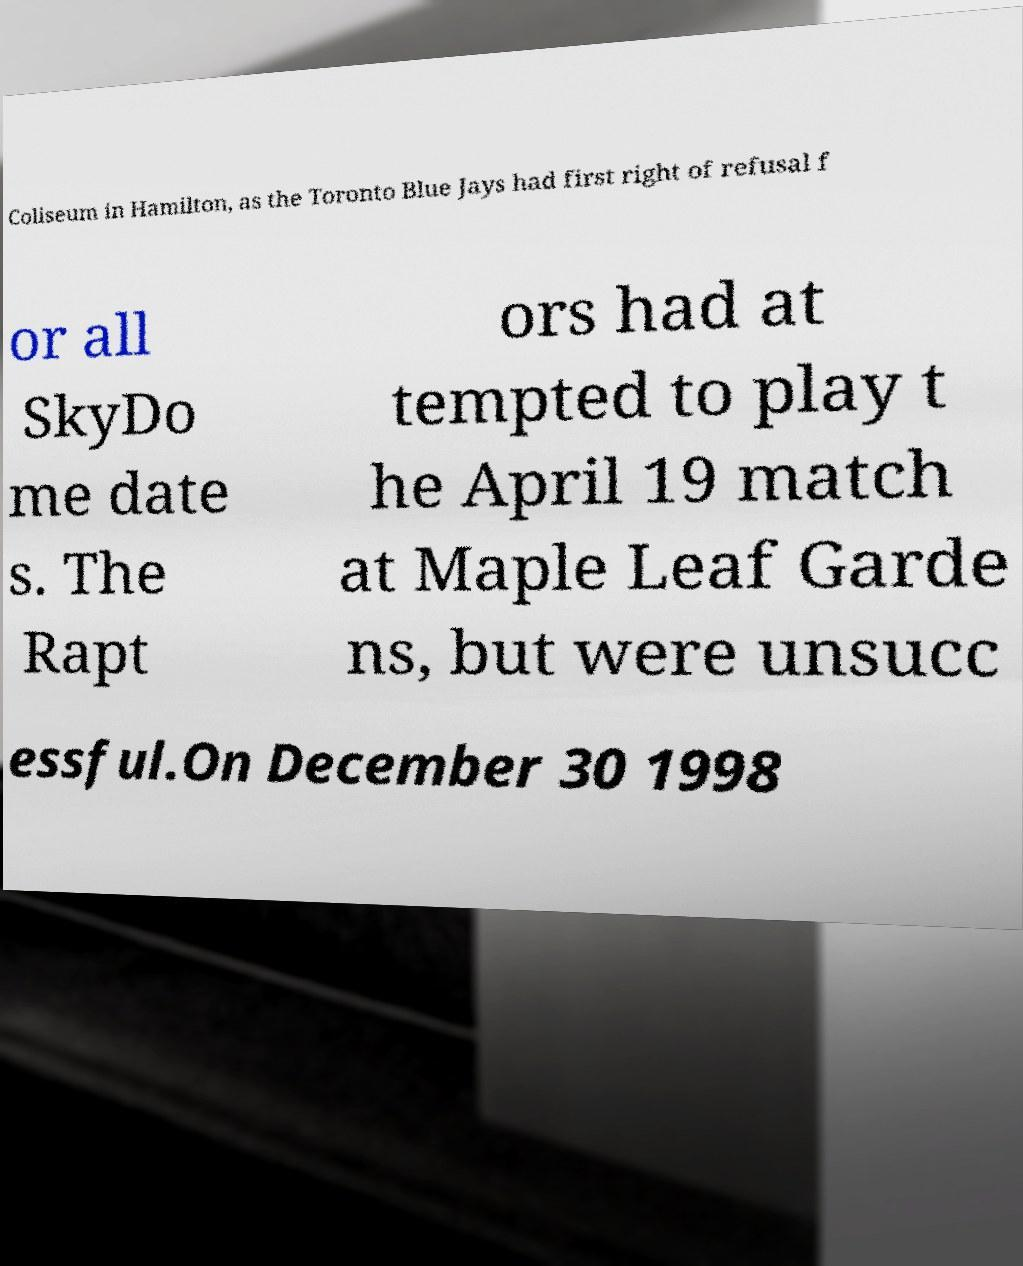Please read and relay the text visible in this image. What does it say? Coliseum in Hamilton, as the Toronto Blue Jays had first right of refusal f or all SkyDo me date s. The Rapt ors had at tempted to play t he April 19 match at Maple Leaf Garde ns, but were unsucc essful.On December 30 1998 